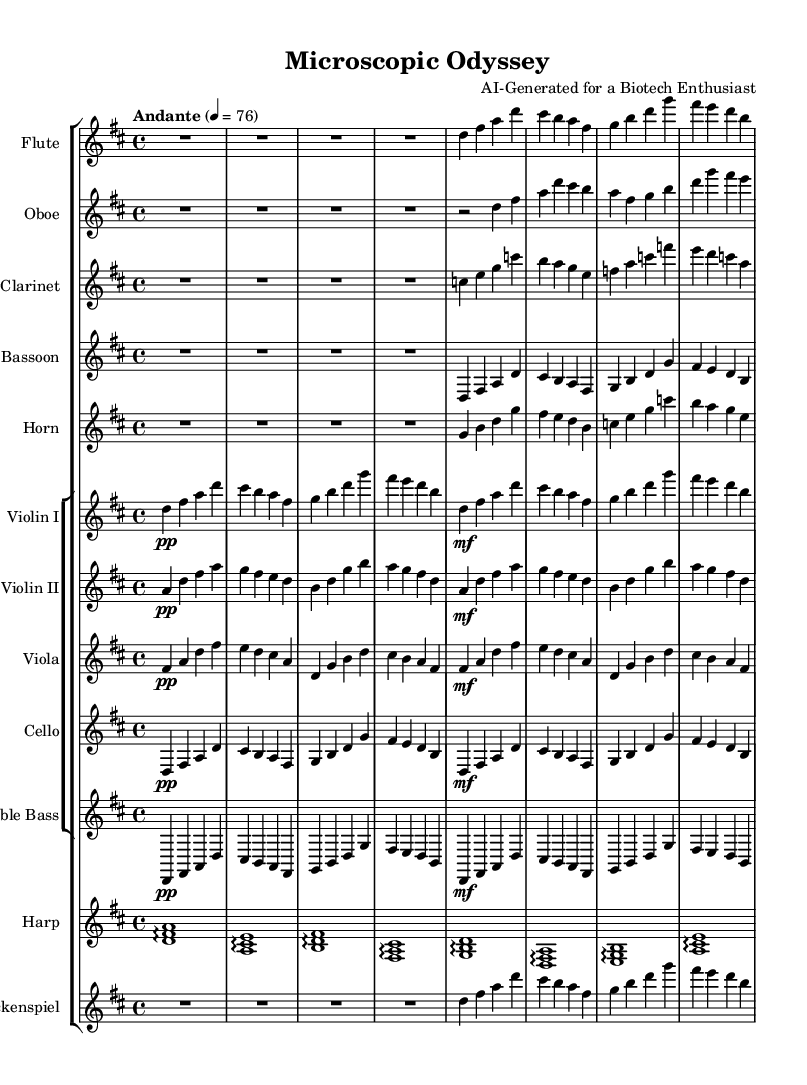What is the key signature of the Symphony? The key signature is D major, which has two sharps. You can identify the key signature on the left side of the staff, where it shows two sharp symbols (F# and C#).
Answer: D major What is the time signature of the piece? The time signature is 4/4, indicated at the beginning of the piece after the key signature. It shows four beats per measure with a quarter note receiving one beat.
Answer: 4/4 What is the tempo marking of this Symphony? The tempo marking is "Andante," which indicates a moderately slow tempo. This marking is placed above the staff at the beginning of the piece alongside the metronome indication (4 = 76).
Answer: Andante Which instrument plays the lowest pitch? The double bass plays the lowest pitch given that it is one of the lowest string instruments in orchestral music and typically holds the bass line within the harmonic structure. The other instruments generally play higher notes.
Answer: Double bass How many different instruments are used in this Symphony? There are twelve instruments used, including woodwinds, brass, strings, harp, and glockenspiel, detailed in the score grouping. You can count the staves at the beginning, one for each instrument.
Answer: Twelve What thematic element is represented by the arpeggios in this piece? The arpeggios played by the harp could symbolize the gentle, flowing movement of exploring the microscopic world. Arpeggios often create a sense of movement and fluidity, which ties to the theme of exploration.
Answer: Exploration 